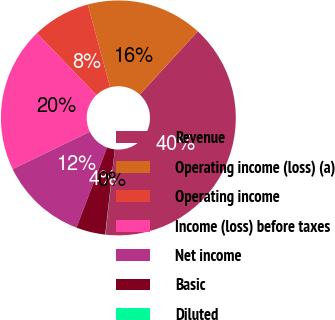Convert chart to OTSL. <chart><loc_0><loc_0><loc_500><loc_500><pie_chart><fcel>Revenue<fcel>Operating income (loss) (a)<fcel>Operating income<fcel>Income (loss) before taxes<fcel>Net income<fcel>Basic<fcel>Diluted<nl><fcel>39.94%<fcel>16.0%<fcel>8.01%<fcel>19.99%<fcel>12.01%<fcel>4.02%<fcel>0.03%<nl></chart> 